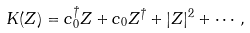<formula> <loc_0><loc_0><loc_500><loc_500>K ( Z ) = c _ { 0 } ^ { \dagger } Z + c _ { 0 } Z ^ { \dagger } + | Z | ^ { 2 } + \cdots ,</formula> 